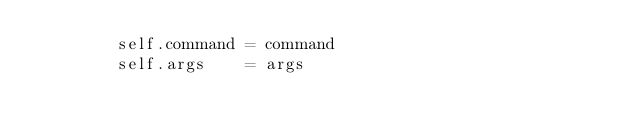Convert code to text. <code><loc_0><loc_0><loc_500><loc_500><_Python_>        self.command = command
        self.args    = args
</code> 